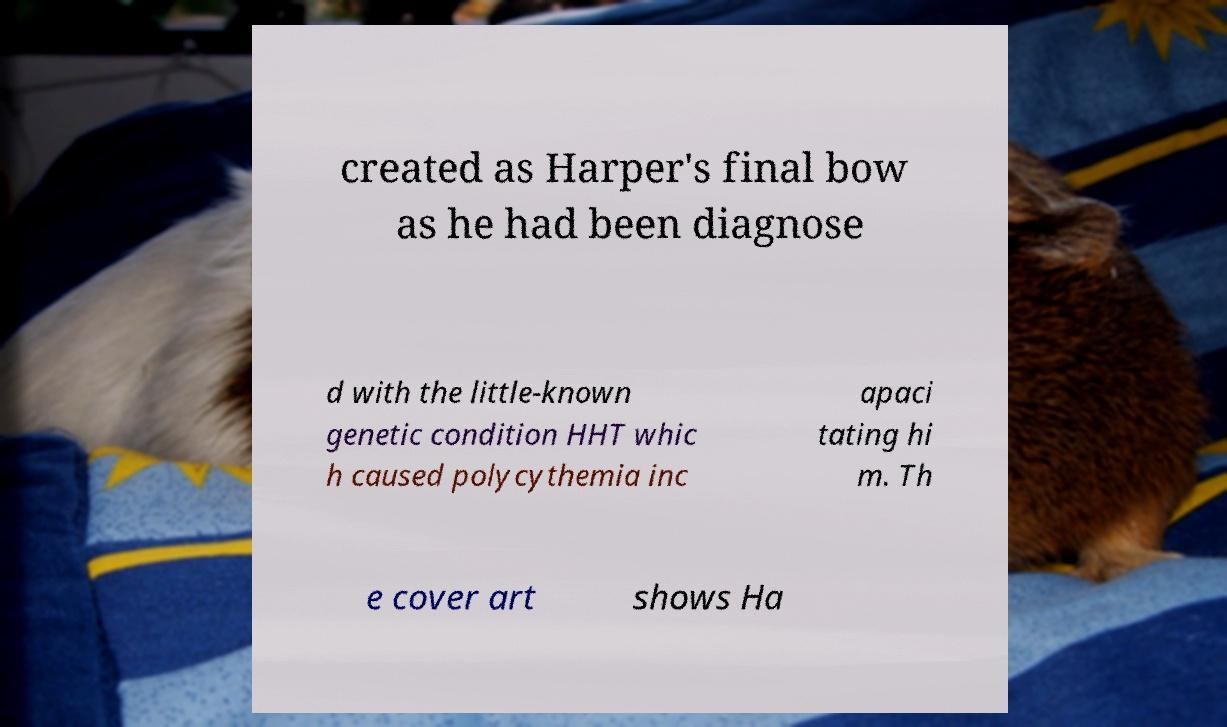There's text embedded in this image that I need extracted. Can you transcribe it verbatim? created as Harper's final bow as he had been diagnose d with the little-known genetic condition HHT whic h caused polycythemia inc apaci tating hi m. Th e cover art shows Ha 